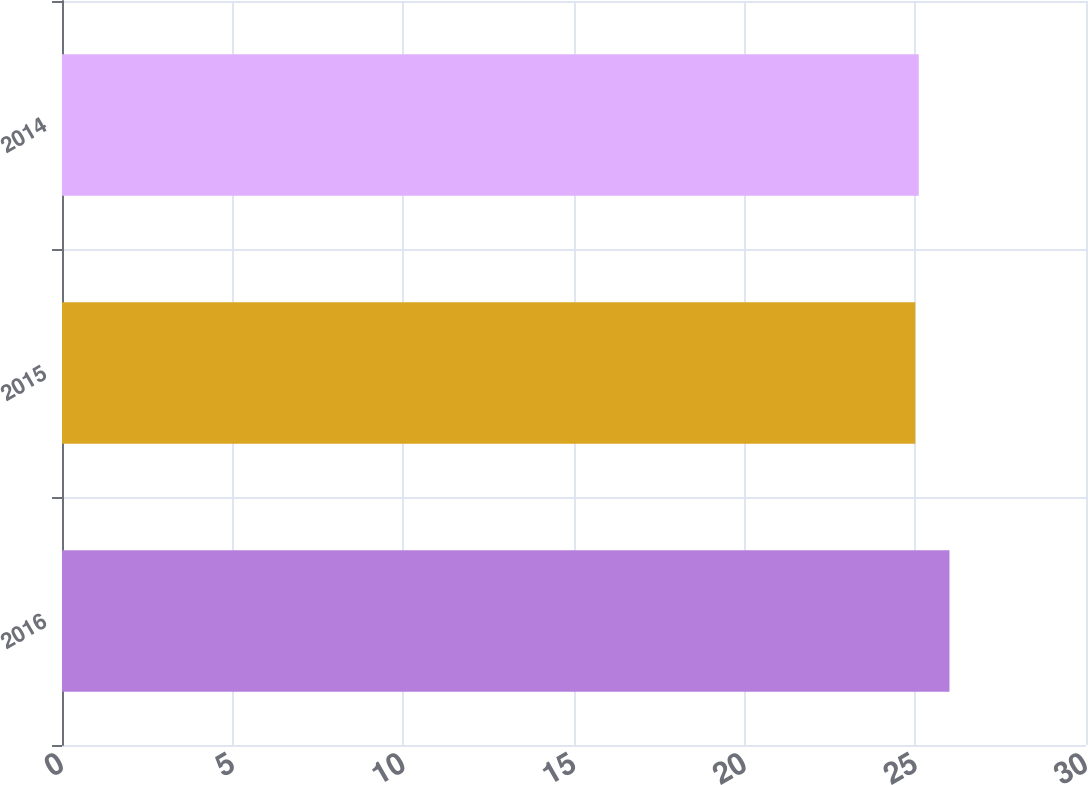<chart> <loc_0><loc_0><loc_500><loc_500><bar_chart><fcel>2016<fcel>2015<fcel>2014<nl><fcel>26<fcel>25<fcel>25.1<nl></chart> 